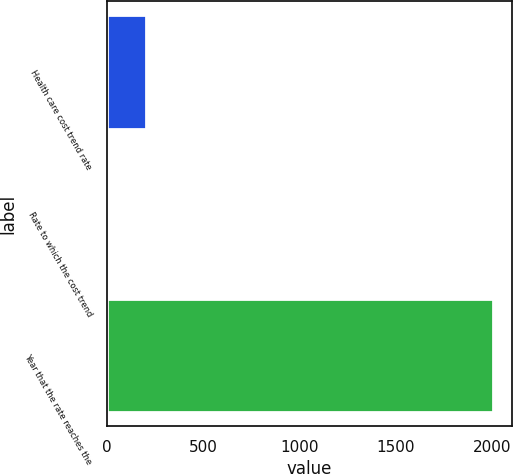Convert chart to OTSL. <chart><loc_0><loc_0><loc_500><loc_500><bar_chart><fcel>Health care cost trend rate<fcel>Rate to which the cost trend<fcel>Year that the rate reaches the<nl><fcel>205.2<fcel>5<fcel>2007<nl></chart> 